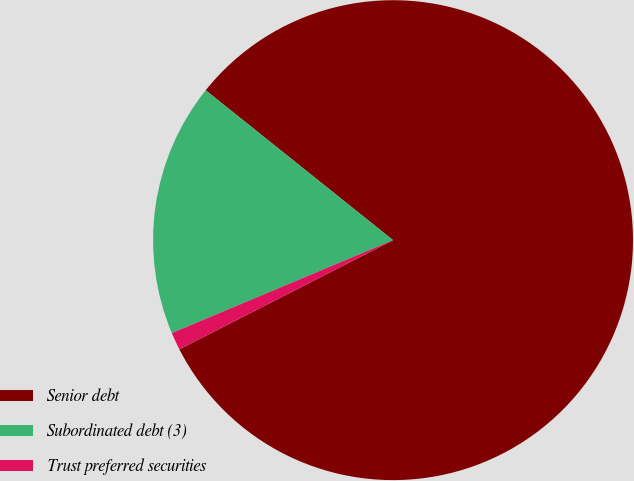Convert chart. <chart><loc_0><loc_0><loc_500><loc_500><pie_chart><fcel>Senior debt<fcel>Subordinated debt (3)<fcel>Trust preferred securities<nl><fcel>81.74%<fcel>17.07%<fcel>1.19%<nl></chart> 